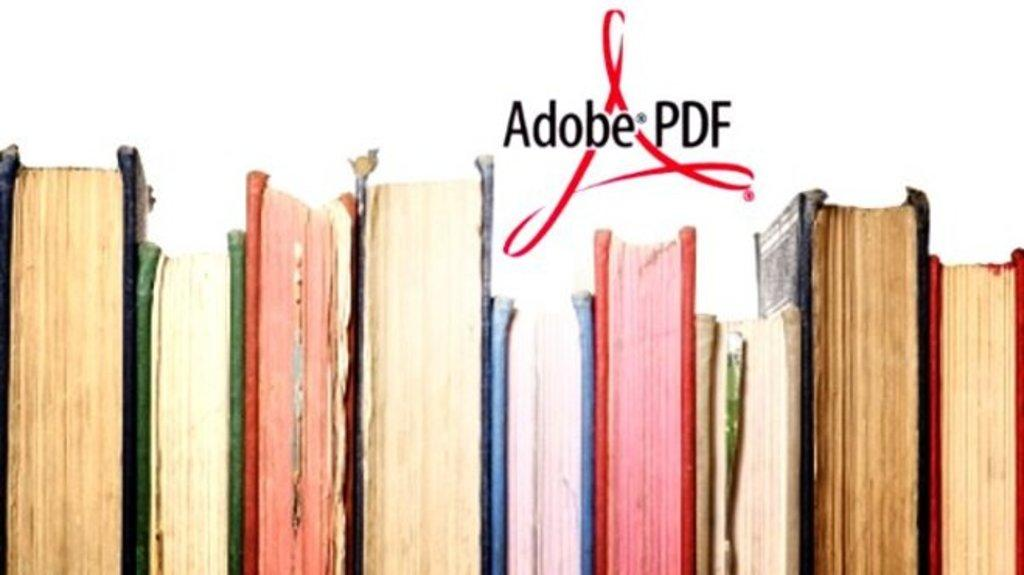<image>
Relay a brief, clear account of the picture shown. An ad for Adobe shows a row of books. 